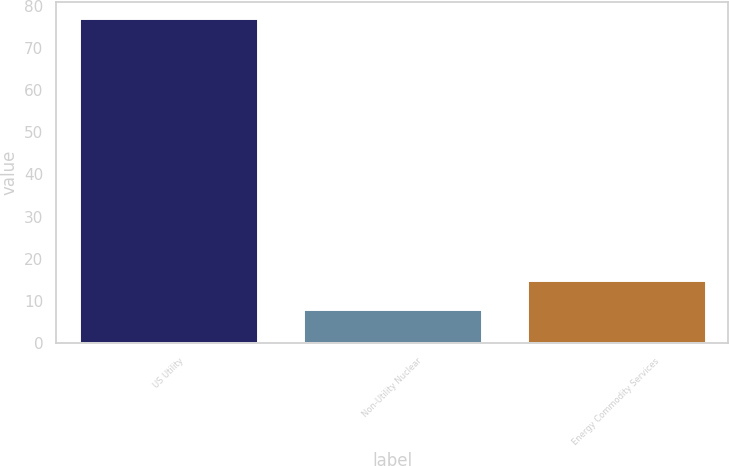Convert chart to OTSL. <chart><loc_0><loc_0><loc_500><loc_500><bar_chart><fcel>US Utility<fcel>Non-Utility Nuclear<fcel>Energy Commodity Services<nl><fcel>77<fcel>8<fcel>14.9<nl></chart> 